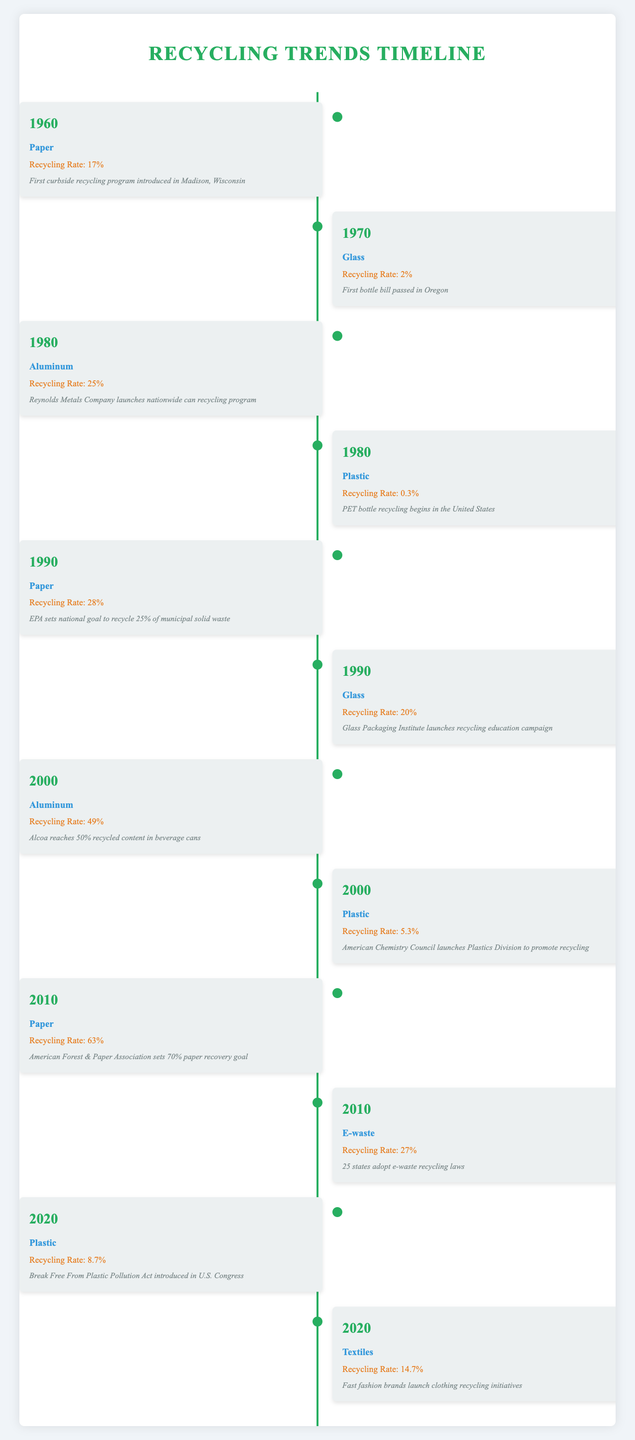What year saw the launch of the first curbside recycling program for paper? The timeline indicates that the first curbside recycling program for paper was introduced in Madison, Wisconsin in 1960.
Answer: 1960 What was the recycling rate for glass in the year 1970? According to the table, the recycling rate for glass in 1970 was 2%.
Answer: 2% Which material had the highest recycling rate in 2010? In 2010, the timeline lists paper with a recycling rate of 63%, which is higher than other materials in that year.
Answer: Paper What is the difference in recycling rates for plastic between 1980 and 2000? The recycling rate for plastic in 1980 was 0.3%, and in 2000 it rose to 5.3%. The difference is 5.3% - 0.3% = 5%.
Answer: 5% Did e-waste have a recycling rate lower than 30% in 2010? The recycling rate for e-waste in 2010 is stated as 27%, which is indeed lower than 30%.
Answer: Yes What was the total recycling rate for paper in 1990 and 2010 combined? In 1990, the recycling rate for paper was 28%, and in 2010 it was 63%. Therefore, combined they total 28% + 63% = 91%.
Answer: 91% In which year did aluminum recycling reach a rate nearest to 50%? Referencing the table, aluminum reached a recycling rate of 49% in the year 2000, which is closest to 50%.
Answer: 2000 What is the average recycling rate for textiles compared to plastics in 2020? The recycling rate for textiles in 2020 was 14.7% and for plastics was 8.7%. The average is (14.7% + 8.7%) / 2 = 11.7%.
Answer: 11.7% Which materials had a recycling rate above 20% in 1990? In 1990, both paper (28%) and glass (20%) had recycling rates that were at or above 20%.
Answer: Paper and Glass 